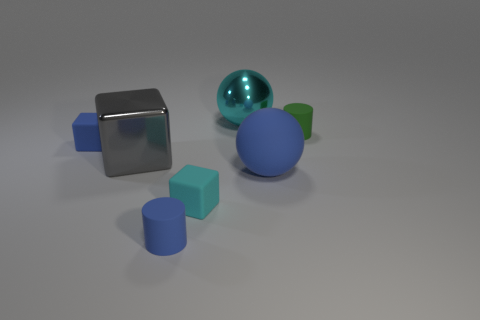How many tiny rubber objects are behind the blue sphere and left of the big rubber ball?
Give a very brief answer. 1. Is there any other thing that is the same shape as the big cyan thing?
Offer a very short reply. Yes. Does the big cube have the same color as the big ball that is on the left side of the big blue rubber sphere?
Give a very brief answer. No. There is a large thing that is on the left side of the big metal sphere; what shape is it?
Your answer should be compact. Cube. What number of other objects are the same material as the blue ball?
Provide a short and direct response. 4. What material is the green cylinder?
Your answer should be compact. Rubber. How many small things are either shiny balls or cyan rubber cubes?
Your response must be concise. 1. There is a big rubber object; how many blue matte objects are behind it?
Provide a short and direct response. 1. Is there a big shiny sphere that has the same color as the large rubber object?
Your answer should be compact. No. There is a gray metallic thing that is the same size as the shiny ball; what shape is it?
Provide a short and direct response. Cube. 